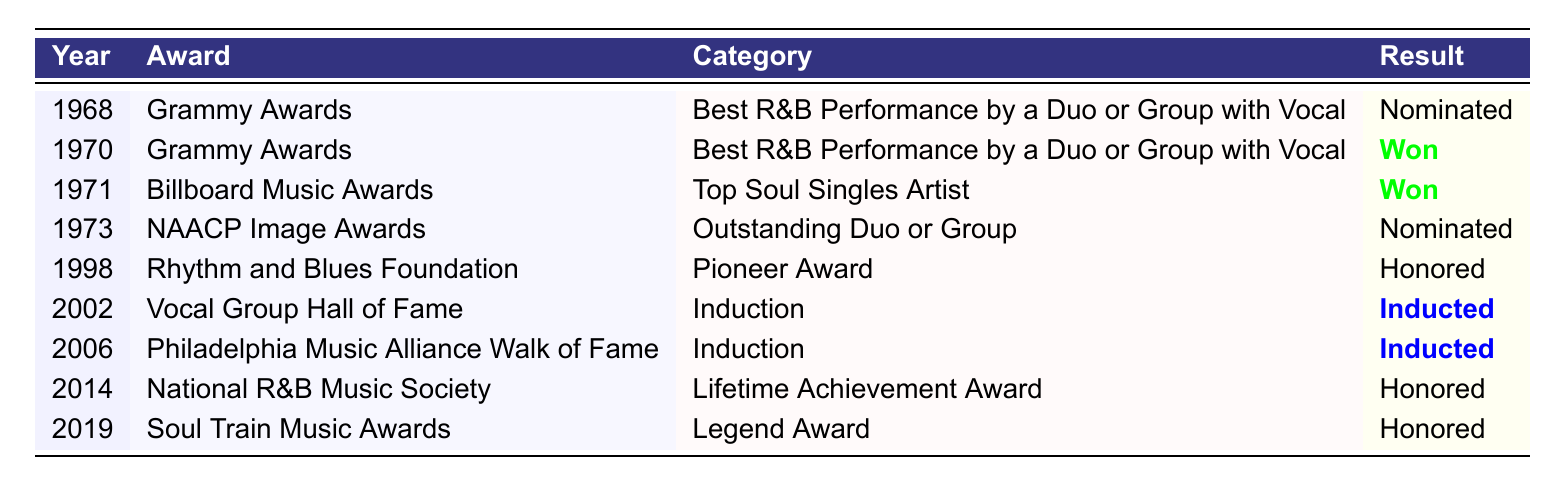What award did The Delfonics win in 1970? The table shows that in 1970, The Delfonics won the Grammy Award for Best R&B Performance by a Duo or Group with Vocal for the nomination "Didn't I (Blow Your Mind This Time)."
Answer: Grammy Award How many awards did The Delfonics receive nominations for throughout their career? The table lists a total of 9 entries, out of which 4 are nominations.
Answer: 4 Did The Delfonics receive any nominations for the NAACP Image Awards? Yes, the table indicates that The Delfonics were nominated for the NAACP Image Award in 1973 for Outstanding Duo or Group.
Answer: Yes In which year did The Delfonics receive the Rhythm and Blues Foundation Pioneer Award? The table states that The Delfonics were honored with the Rhythm and Blues Foundation Pioneer Award in 1998.
Answer: 1998 What is the total number of categories in which The Delfonics won awards? The table contains 3 awards that The Delfonics won: the Grammy Award in 1970 and the Billboard Music Award in 1971. Thus, the total is 2.
Answer: 2 Which award did The Delfonics receive for the induction in Vocal Group Hall of Fame? According to the table, The Delfonics were inducted into the Vocal Group Hall of Fame in 2002.
Answer: Inducted What was the result of The Delfonics' nomination at the 2014 National R&B Music Society? The table shows that The Delfonics were honored by the National R&B Music Society with a Lifetime Achievement Award in 2014.
Answer: Honored In which two years did The Delfonics receive induction honors? The Delfonics received induction honors in 2002 to the Vocal Group Hall of Fame and in 2006 to the Philadelphia Music Alliance Walk of Fame.
Answer: 2002 and 2006 Which award was received by The Delfonics in 2019? The table indicates that The Delfonics were honored with the Legend Award at the Soul Train Music Awards in 2019.
Answer: Legend Award Was there any year when The Delfonics were nominated for an award but did not win? Yes, the table records multiple nominations, including the Grammy Awards in 1968 and the NAACP Image Awards in 1973, both of which did not result in wins.
Answer: Yes 